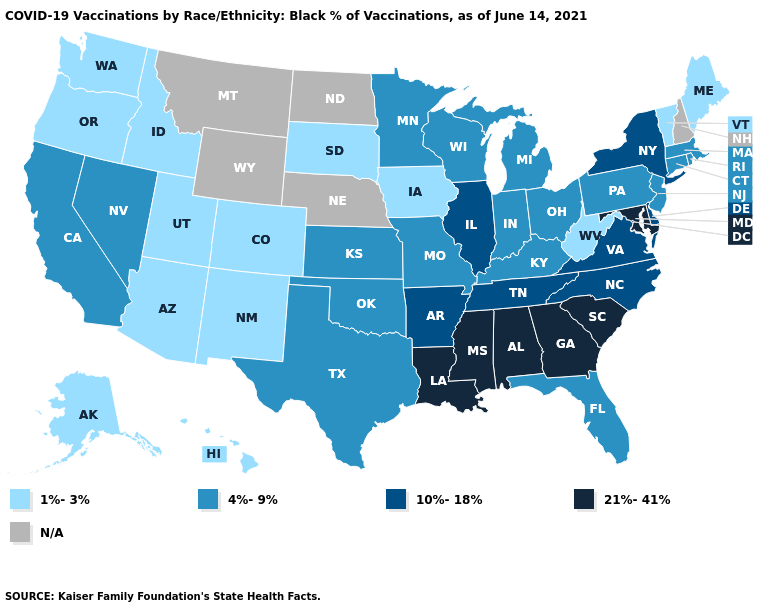Name the states that have a value in the range N/A?
Keep it brief. Montana, Nebraska, New Hampshire, North Dakota, Wyoming. What is the lowest value in states that border Oklahoma?
Write a very short answer. 1%-3%. Which states have the lowest value in the MidWest?
Quick response, please. Iowa, South Dakota. Name the states that have a value in the range 10%-18%?
Short answer required. Arkansas, Delaware, Illinois, New York, North Carolina, Tennessee, Virginia. Does the map have missing data?
Concise answer only. Yes. What is the value of Illinois?
Keep it brief. 10%-18%. Name the states that have a value in the range 1%-3%?
Short answer required. Alaska, Arizona, Colorado, Hawaii, Idaho, Iowa, Maine, New Mexico, Oregon, South Dakota, Utah, Vermont, Washington, West Virginia. Among the states that border Wyoming , which have the lowest value?
Quick response, please. Colorado, Idaho, South Dakota, Utah. What is the value of Rhode Island?
Write a very short answer. 4%-9%. How many symbols are there in the legend?
Quick response, please. 5. What is the value of New York?
Write a very short answer. 10%-18%. Among the states that border Georgia , does South Carolina have the highest value?
Keep it brief. Yes. What is the value of Kentucky?
Quick response, please. 4%-9%. What is the value of Nevada?
Give a very brief answer. 4%-9%. 